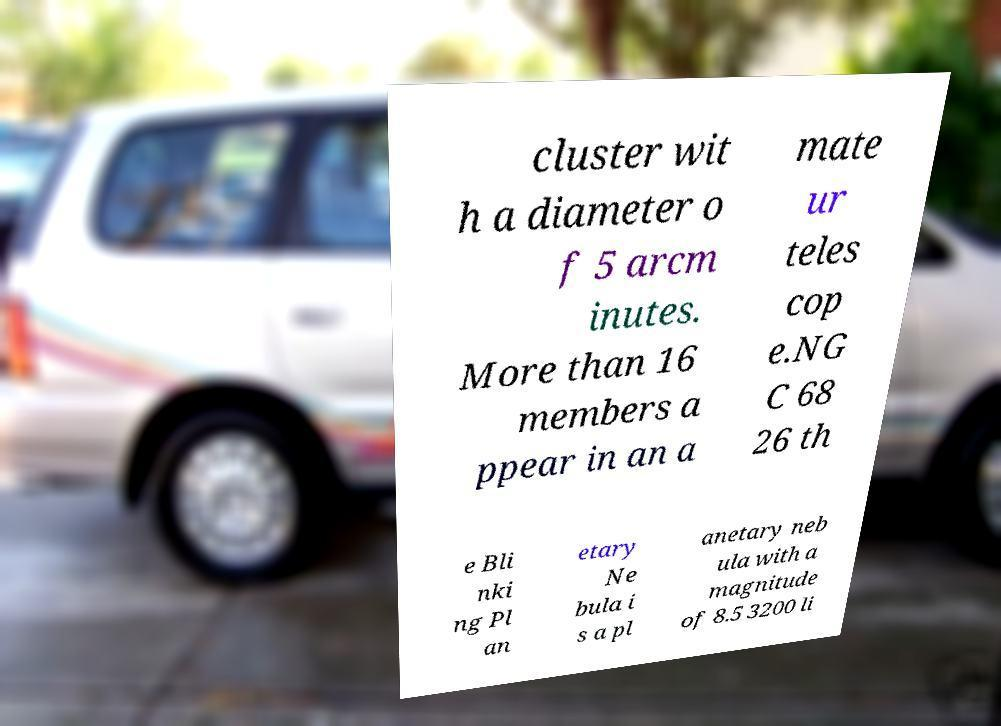Can you read and provide the text displayed in the image?This photo seems to have some interesting text. Can you extract and type it out for me? cluster wit h a diameter o f 5 arcm inutes. More than 16 members a ppear in an a mate ur teles cop e.NG C 68 26 th e Bli nki ng Pl an etary Ne bula i s a pl anetary neb ula with a magnitude of 8.5 3200 li 